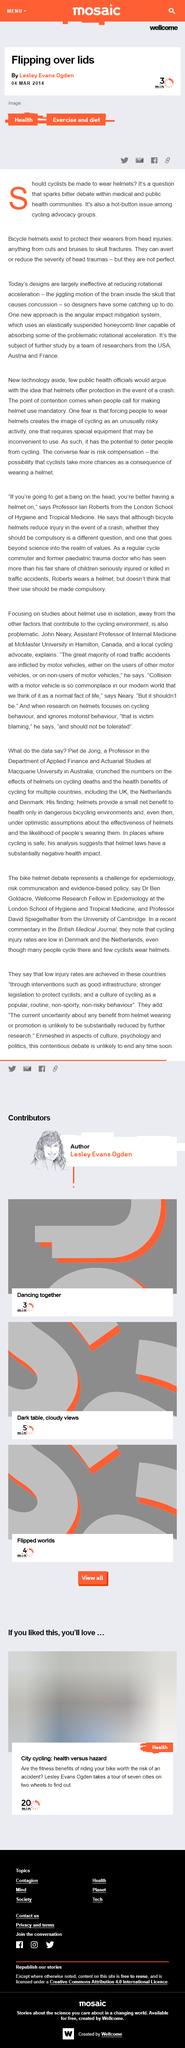Give some essential details in this illustration. The controversial issue of whether cyclists should be required to wear helmets has sparked a heated debate among medical and public health professionals. The article "Flipping over lids," dated March 4, 2014, was written by Lesley Evans Ogden. Bicycle helmets exist to protect their wearers from head injuries resulting from accidents while riding a bicycle. 